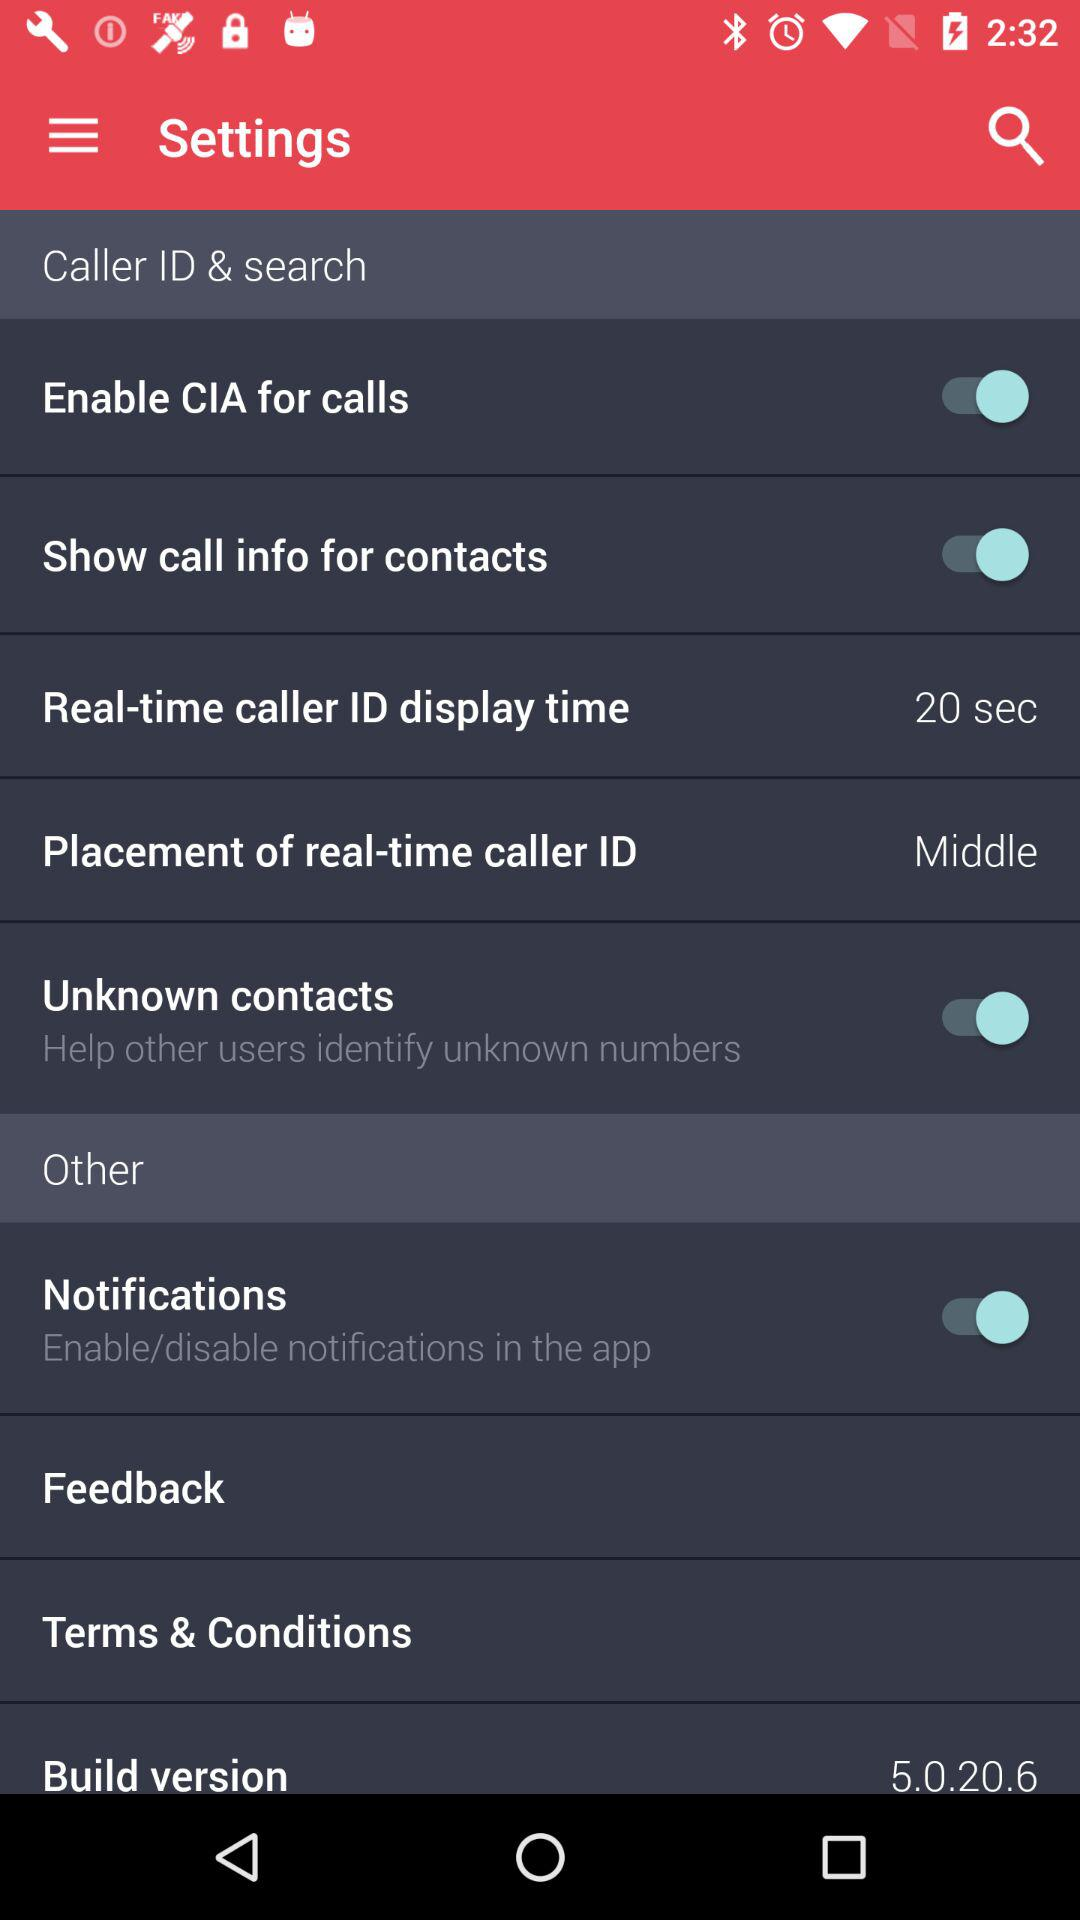How many items are in the "Other" section?
Answer the question using a single word or phrase. 4 